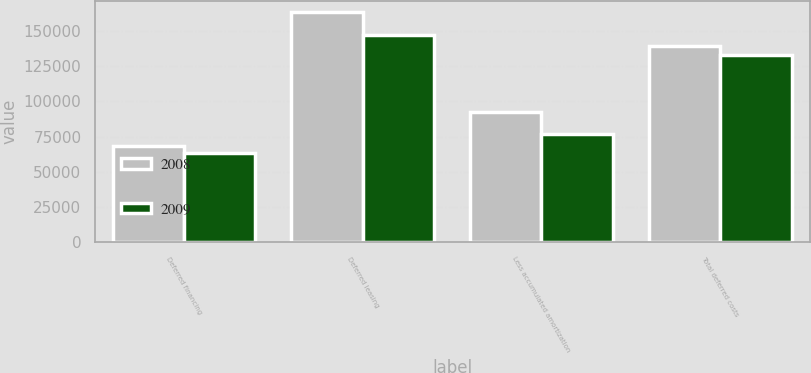<chart> <loc_0><loc_0><loc_500><loc_500><stacked_bar_chart><ecel><fcel>Deferred financing<fcel>Deferred leasing<fcel>Less accumulated amortization<fcel>Total deferred costs<nl><fcel>2008<fcel>68181<fcel>163372<fcel>92296<fcel>139257<nl><fcel>2009<fcel>63262<fcel>146951<fcel>77161<fcel>133052<nl></chart> 